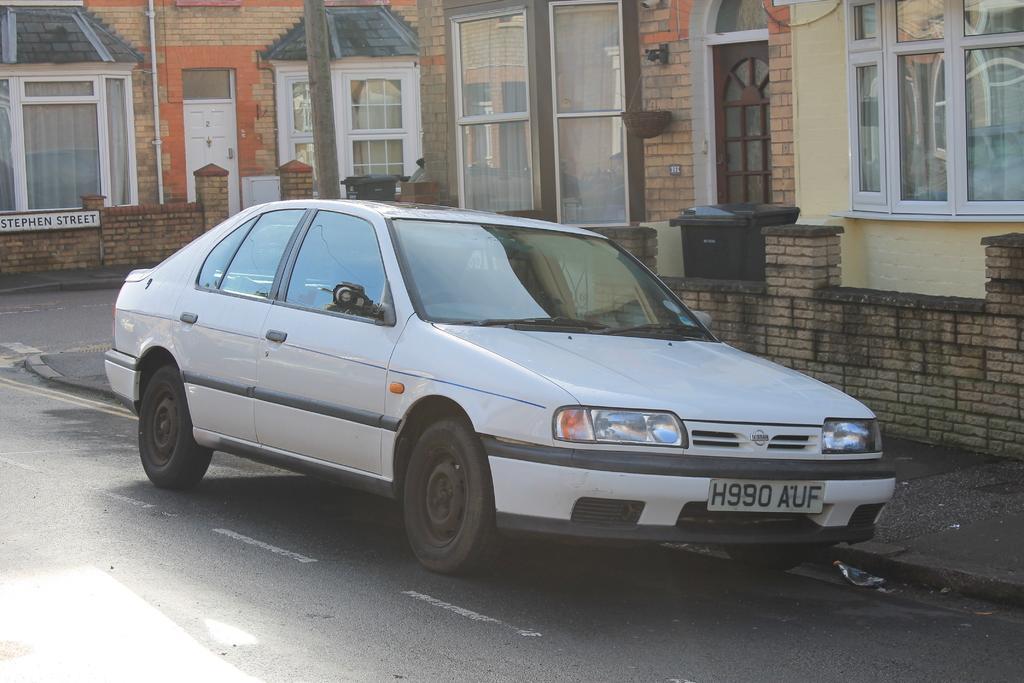In one or two sentences, can you explain what this image depicts? In this image we can see a car. Behind the car we can see buildings, dustbin and the walls. On the buildings we can see the windows with glasses. On the left side, we can see a board with text attached to a wall. 